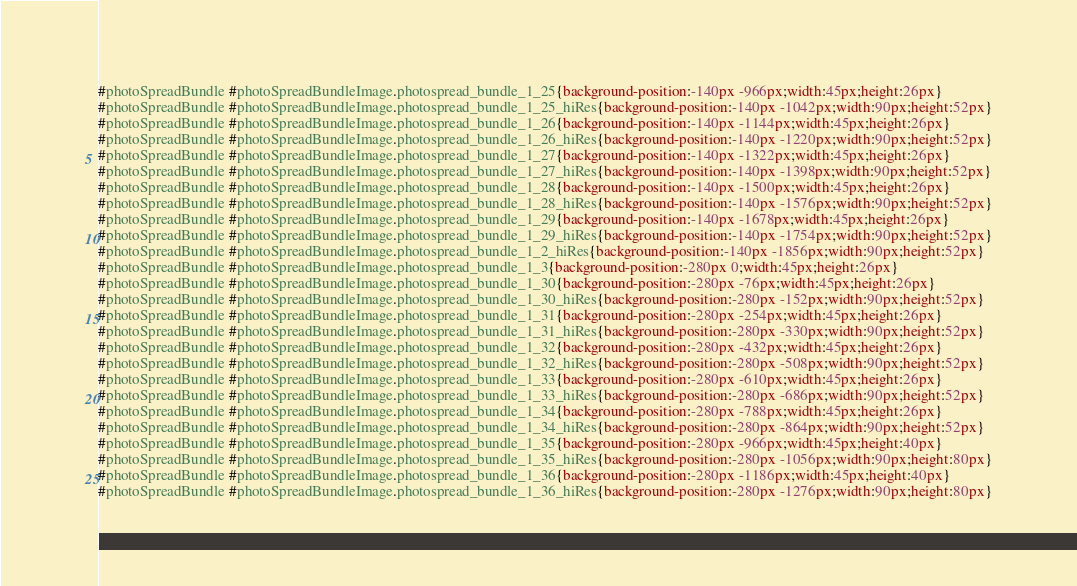Convert code to text. <code><loc_0><loc_0><loc_500><loc_500><_CSS_>#photoSpreadBundle #photoSpreadBundleImage.photospread_bundle_1_25{background-position:-140px -966px;width:45px;height:26px}
#photoSpreadBundle #photoSpreadBundleImage.photospread_bundle_1_25_hiRes{background-position:-140px -1042px;width:90px;height:52px}
#photoSpreadBundle #photoSpreadBundleImage.photospread_bundle_1_26{background-position:-140px -1144px;width:45px;height:26px}
#photoSpreadBundle #photoSpreadBundleImage.photospread_bundle_1_26_hiRes{background-position:-140px -1220px;width:90px;height:52px}
#photoSpreadBundle #photoSpreadBundleImage.photospread_bundle_1_27{background-position:-140px -1322px;width:45px;height:26px}
#photoSpreadBundle #photoSpreadBundleImage.photospread_bundle_1_27_hiRes{background-position:-140px -1398px;width:90px;height:52px}
#photoSpreadBundle #photoSpreadBundleImage.photospread_bundle_1_28{background-position:-140px -1500px;width:45px;height:26px}
#photoSpreadBundle #photoSpreadBundleImage.photospread_bundle_1_28_hiRes{background-position:-140px -1576px;width:90px;height:52px}
#photoSpreadBundle #photoSpreadBundleImage.photospread_bundle_1_29{background-position:-140px -1678px;width:45px;height:26px}
#photoSpreadBundle #photoSpreadBundleImage.photospread_bundle_1_29_hiRes{background-position:-140px -1754px;width:90px;height:52px}
#photoSpreadBundle #photoSpreadBundleImage.photospread_bundle_1_2_hiRes{background-position:-140px -1856px;width:90px;height:52px}
#photoSpreadBundle #photoSpreadBundleImage.photospread_bundle_1_3{background-position:-280px 0;width:45px;height:26px}
#photoSpreadBundle #photoSpreadBundleImage.photospread_bundle_1_30{background-position:-280px -76px;width:45px;height:26px}
#photoSpreadBundle #photoSpreadBundleImage.photospread_bundle_1_30_hiRes{background-position:-280px -152px;width:90px;height:52px}
#photoSpreadBundle #photoSpreadBundleImage.photospread_bundle_1_31{background-position:-280px -254px;width:45px;height:26px}
#photoSpreadBundle #photoSpreadBundleImage.photospread_bundle_1_31_hiRes{background-position:-280px -330px;width:90px;height:52px}
#photoSpreadBundle #photoSpreadBundleImage.photospread_bundle_1_32{background-position:-280px -432px;width:45px;height:26px}
#photoSpreadBundle #photoSpreadBundleImage.photospread_bundle_1_32_hiRes{background-position:-280px -508px;width:90px;height:52px}
#photoSpreadBundle #photoSpreadBundleImage.photospread_bundle_1_33{background-position:-280px -610px;width:45px;height:26px}
#photoSpreadBundle #photoSpreadBundleImage.photospread_bundle_1_33_hiRes{background-position:-280px -686px;width:90px;height:52px}
#photoSpreadBundle #photoSpreadBundleImage.photospread_bundle_1_34{background-position:-280px -788px;width:45px;height:26px}
#photoSpreadBundle #photoSpreadBundleImage.photospread_bundle_1_34_hiRes{background-position:-280px -864px;width:90px;height:52px}
#photoSpreadBundle #photoSpreadBundleImage.photospread_bundle_1_35{background-position:-280px -966px;width:45px;height:40px}
#photoSpreadBundle #photoSpreadBundleImage.photospread_bundle_1_35_hiRes{background-position:-280px -1056px;width:90px;height:80px}
#photoSpreadBundle #photoSpreadBundleImage.photospread_bundle_1_36{background-position:-280px -1186px;width:45px;height:40px}
#photoSpreadBundle #photoSpreadBundleImage.photospread_bundle_1_36_hiRes{background-position:-280px -1276px;width:90px;height:80px}</code> 